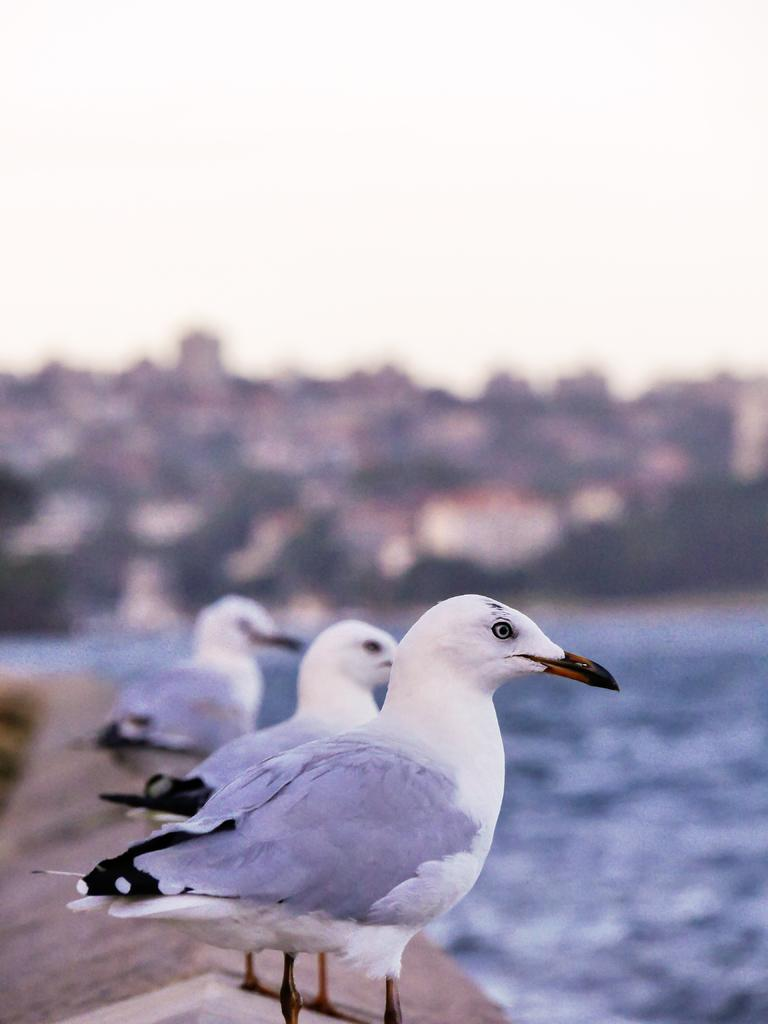What is located on the wall in the foreground of the image? There are three birds on the wall in the foreground of the image. What can be seen on the right side of the image? There appears to be water on the right side of the image. What type of structures are visible in the background of the image? There are buildings visible in the background of the image. What type of vegetation is present in the background of the image? There are trees present in the background of the image. What color is the mist in the image? There is no mist present in the image. How many tails can be seen on the birds in the image? The image does not show the birds' tails, so it is not possible to determine the number of tails. 